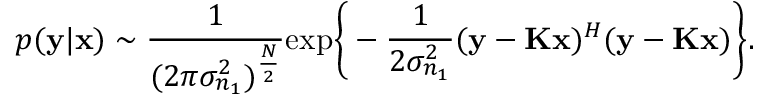<formula> <loc_0><loc_0><loc_500><loc_500>p ( { y | { x } } ) \sim \frac { 1 } { ( { 2 \pi } { { \sigma _ { n _ { 1 } } ^ { 2 } } } ) ^ { \frac { N } { 2 } } } e x p \left \{ - \frac { 1 } { 2 { \sigma _ { n _ { 1 } } ^ { 2 } } } ( { y } - { K } { x } ) ^ { H } ( { y } - { K } { x } ) \right \} .</formula> 